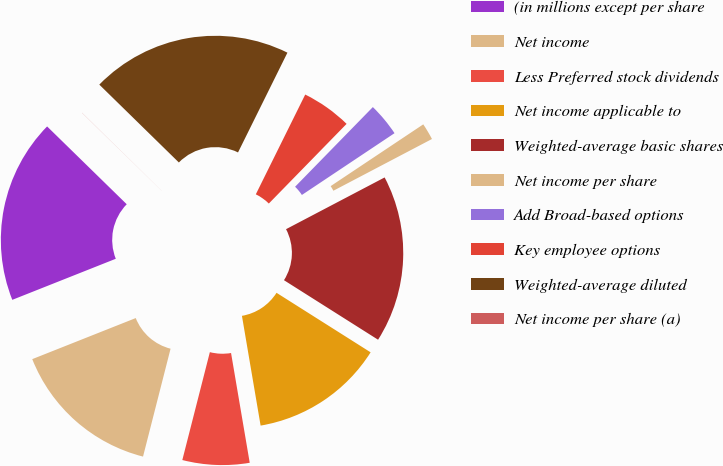Convert chart. <chart><loc_0><loc_0><loc_500><loc_500><pie_chart><fcel>(in millions except per share<fcel>Net income<fcel>Less Preferred stock dividends<fcel>Net income applicable to<fcel>Weighted-average basic shares<fcel>Net income per share<fcel>Add Broad-based options<fcel>Key employee options<fcel>Weighted-average diluted<fcel>Net income per share (a)<nl><fcel>18.33%<fcel>15.01%<fcel>6.66%<fcel>13.34%<fcel>16.67%<fcel>1.67%<fcel>3.33%<fcel>4.99%<fcel>19.99%<fcel>0.01%<nl></chart> 